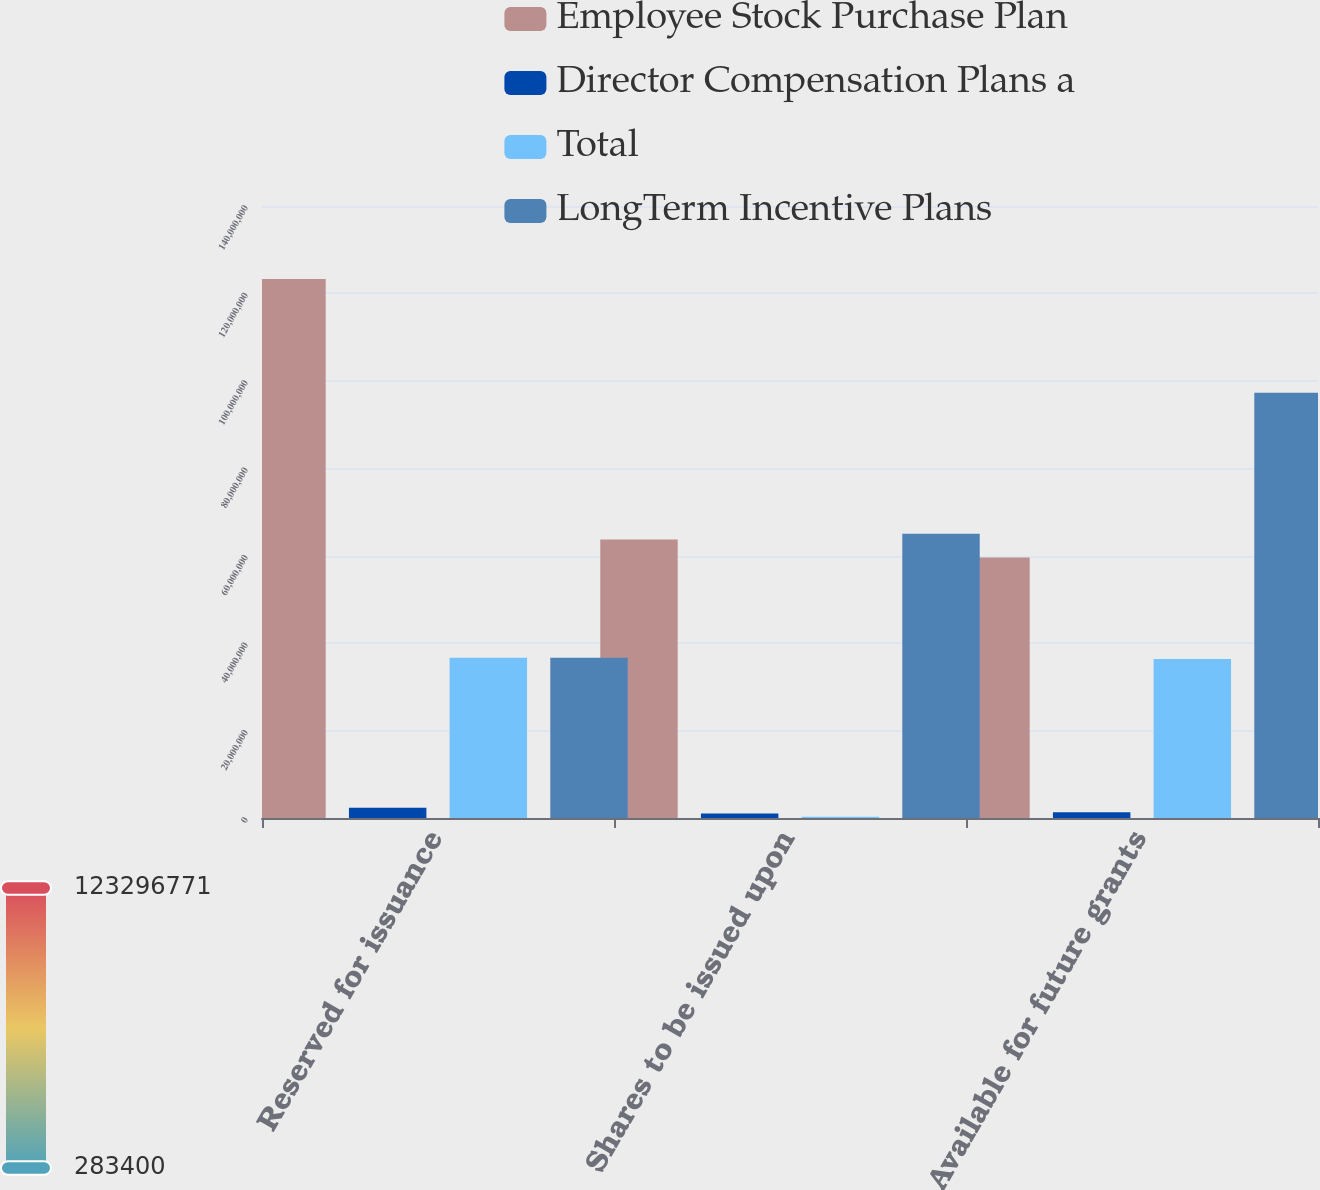<chart> <loc_0><loc_0><loc_500><loc_500><stacked_bar_chart><ecel><fcel>Reserved for issuance<fcel>Shares to be issued upon<fcel>Available for future grants<nl><fcel>Employee Stock Purchase Plan<fcel>1.23297e+08<fcel>6.37152e+07<fcel>5.95816e+07<nl><fcel>Director Compensation Plans a<fcel>2.34127e+06<fcel>1.02663e+06<fcel>1.31465e+06<nl><fcel>Total<fcel>3.66706e+07<fcel>283400<fcel>3.63872e+07<nl><fcel>LongTerm Incentive Plans<fcel>3.66706e+07<fcel>6.50252e+07<fcel>9.72834e+07<nl></chart> 